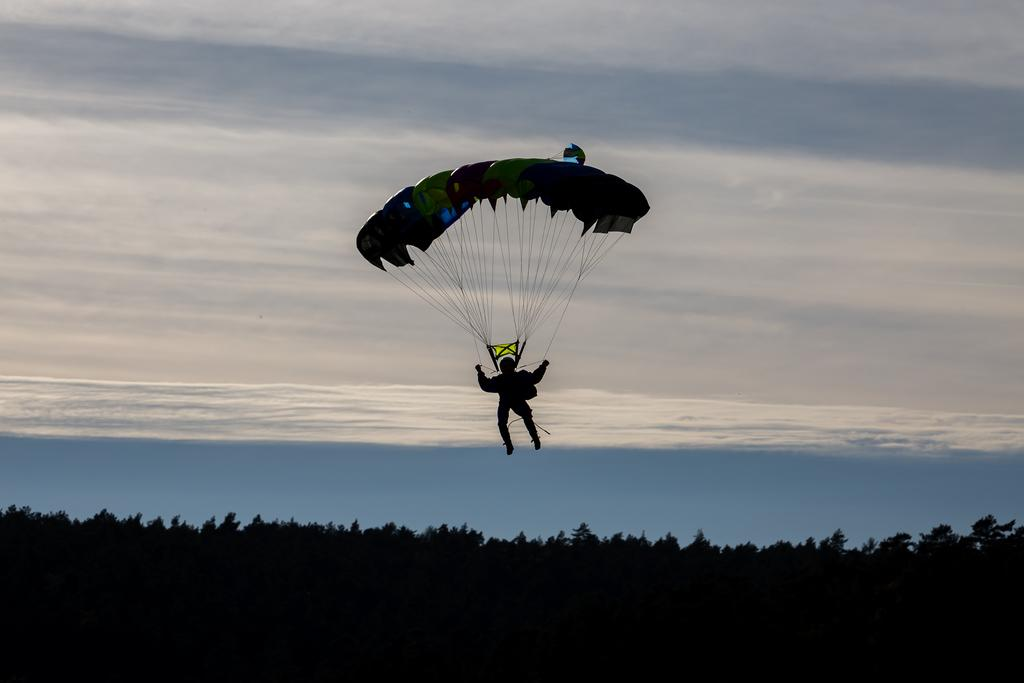What is the person in the image doing? The person is flying in the air. How is the person able to fly in the air? The person is tied to a parachute. What can be seen at the bottom of the image? There are trees at the bottom of the image. What is visible in the sky in the background? There are clouds in the sky in the background. What type of cobweb can be seen in the image? There is no cobweb present in the image. In which direction is the person flying in the image? The direction in which the person is flying cannot be determined from the image alone. 